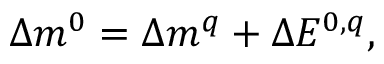<formula> <loc_0><loc_0><loc_500><loc_500>\Delta m ^ { 0 } = \Delta m ^ { q } + \Delta E ^ { 0 , q } ,</formula> 